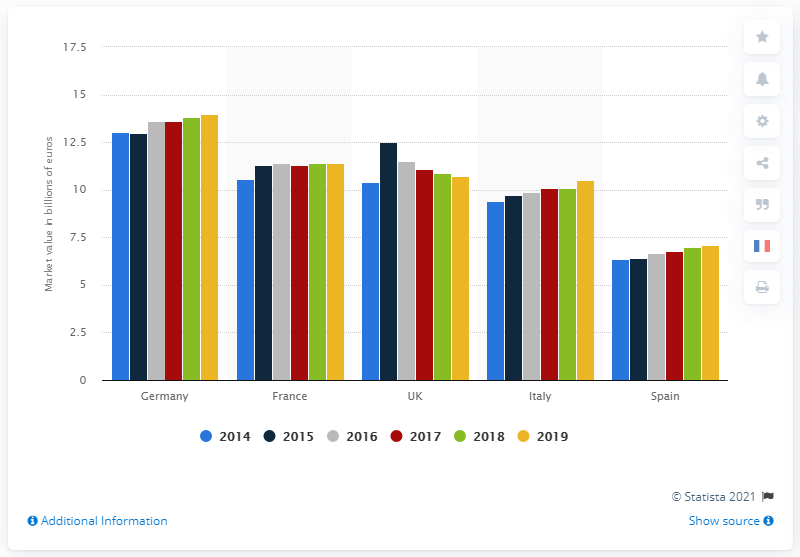Point out several critical features in this image. During the period between 2015 and 2019, the market value of the French market was estimated to be approximately 14... In 2019, Germany's market value was approximately 14. 